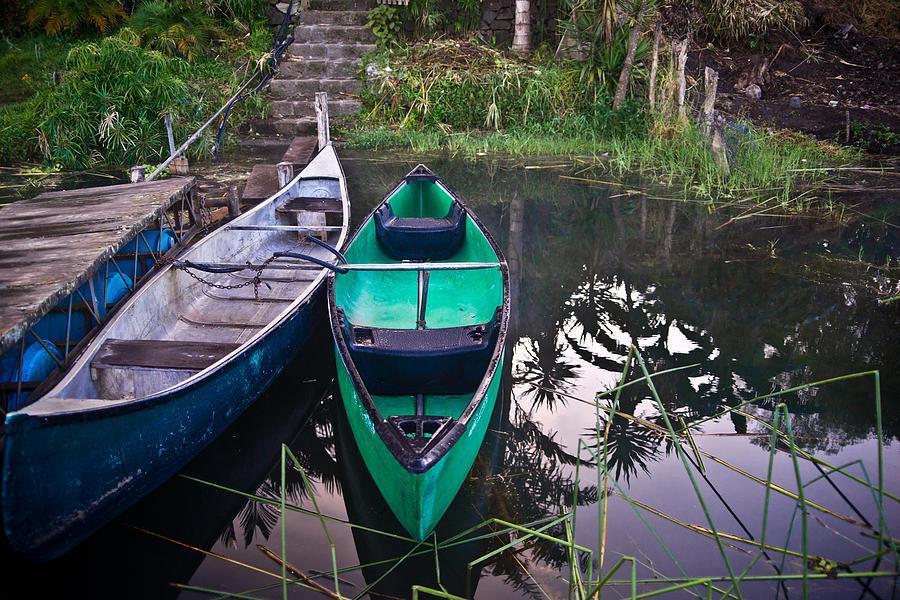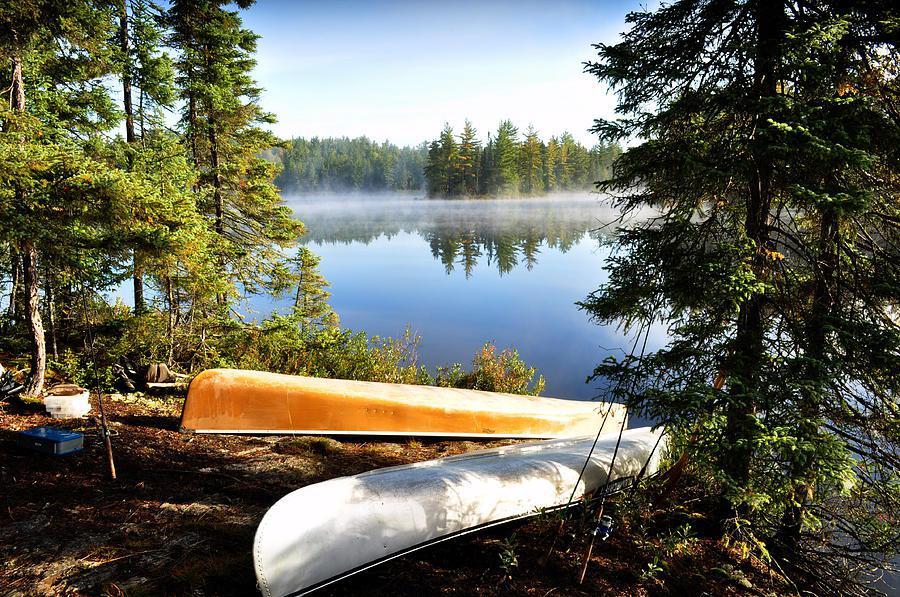The first image is the image on the left, the second image is the image on the right. Considering the images on both sides, is "At least one boat has at least one person sitting in it." valid? Answer yes or no. No. The first image is the image on the left, the second image is the image on the right. For the images shown, is this caption "Two canoes are upside down." true? Answer yes or no. Yes. 